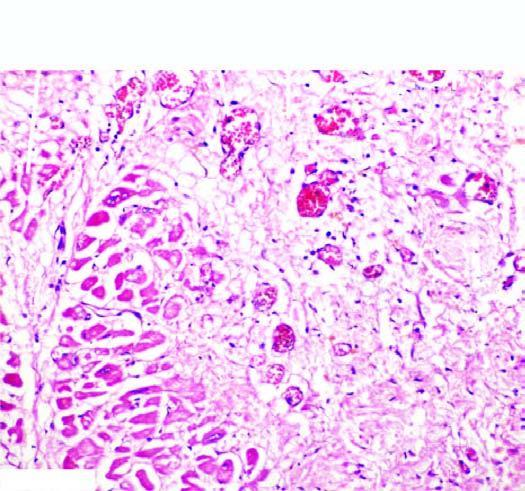what does the infarcted area show?
Answer the question using a single word or phrase. Ingrowth of inflammatory granulation tissue 